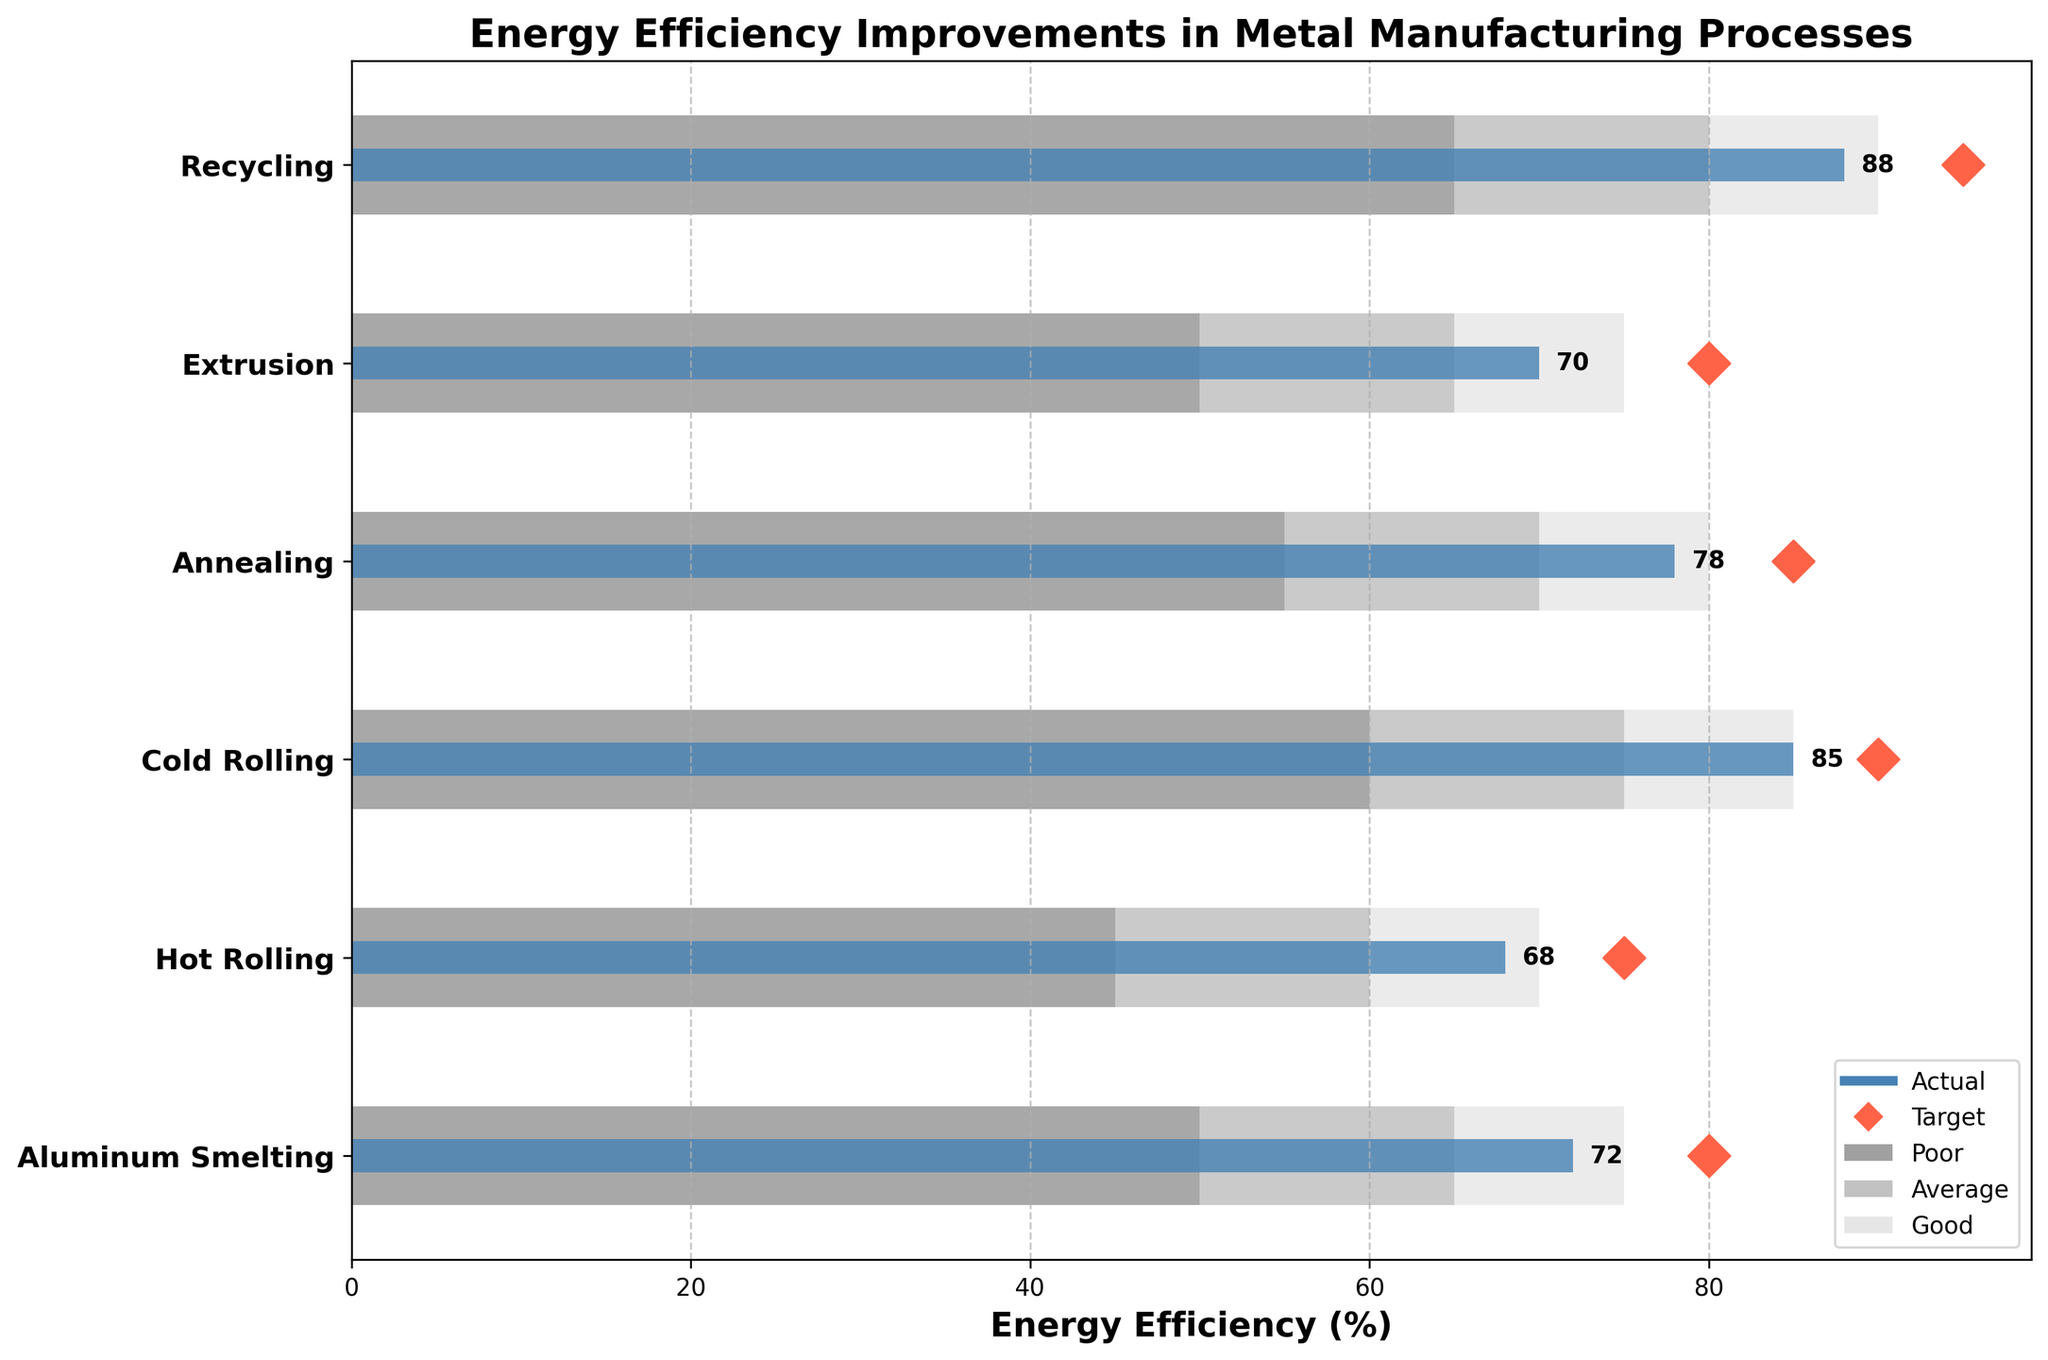What is the title of the chart? The title is located at the top of the chart and is the main heading that describes the content of the chart. It reads "Energy Efficiency Improvements in Metal Manufacturing Processes".
Answer: Energy Efficiency Improvements in Metal Manufacturing Processes What is the unit of measurement on the x-axis? The x-axis label provides the unit of measurement, which is "Energy Efficiency (%)".
Answer: Energy Efficiency (%) Which process has the highest actual energy efficiency value? By observing the length of the blue bars representing the actual values, we can determine which one is the longest. Recycling has the highest actual value noted as 88%.
Answer: Recycling What is the difference between the actual and target value for Annealing? Annealing's actual value is shown as 78% and its target value is represented by the red diamond at 85%. The difference is calculated as 85 - 78.
Answer: 7% How many processes have actual values higher than their target values? To find this, compare the position of the blue bars (actual values) relative to red diamonds (target values). None of the processes have actual values exceeding their target values.
Answer: 0 Which process falls into the 'Poor' range but has the highest actual value within that range? The 'Poor' range is represented by the darkest grey bars. Hot Rolling has the highest actual value of 68% within this range.
Answer: Hot Rolling Is the actual energy efficiency value of Cold Rolling within the 'Good' range? Firstly, note that Cold Rolling has an actual value of 85%. The 'Good' range for Cold Rolling is 75-85%. Since 85% is at the boundary of the 'Good' range, it qualifies.
Answer: Yes What is the average target value for all processes? Add the target values for each process (80, 75, 90, 85, 80, 95), resulting in 505. Then divide by the number of processes (6).
Answer: 84.17 Which process has the smallest gap between its actual and target value? Calculate the gaps for each process by subtracting actual values from their respective target values: Aluminum Smelting (8), Hot Rolling (7), Cold Rolling (5), Annealing (7), Extrusion (10), Recycling (7). Cold Rolling has the smallest gap.
Answer: Cold Rolling 